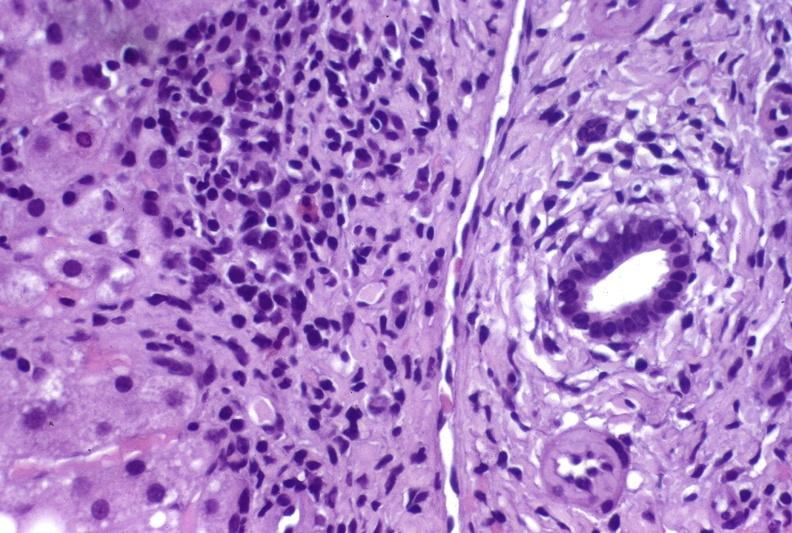s liver present?
Answer the question using a single word or phrase. Yes 